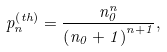Convert formula to latex. <formula><loc_0><loc_0><loc_500><loc_500>p _ { n } ^ { \left ( t h \right ) } = \frac { n _ { 0 } ^ { n } } { \left ( n _ { 0 } + 1 \right ) ^ { n + 1 } } ,</formula> 